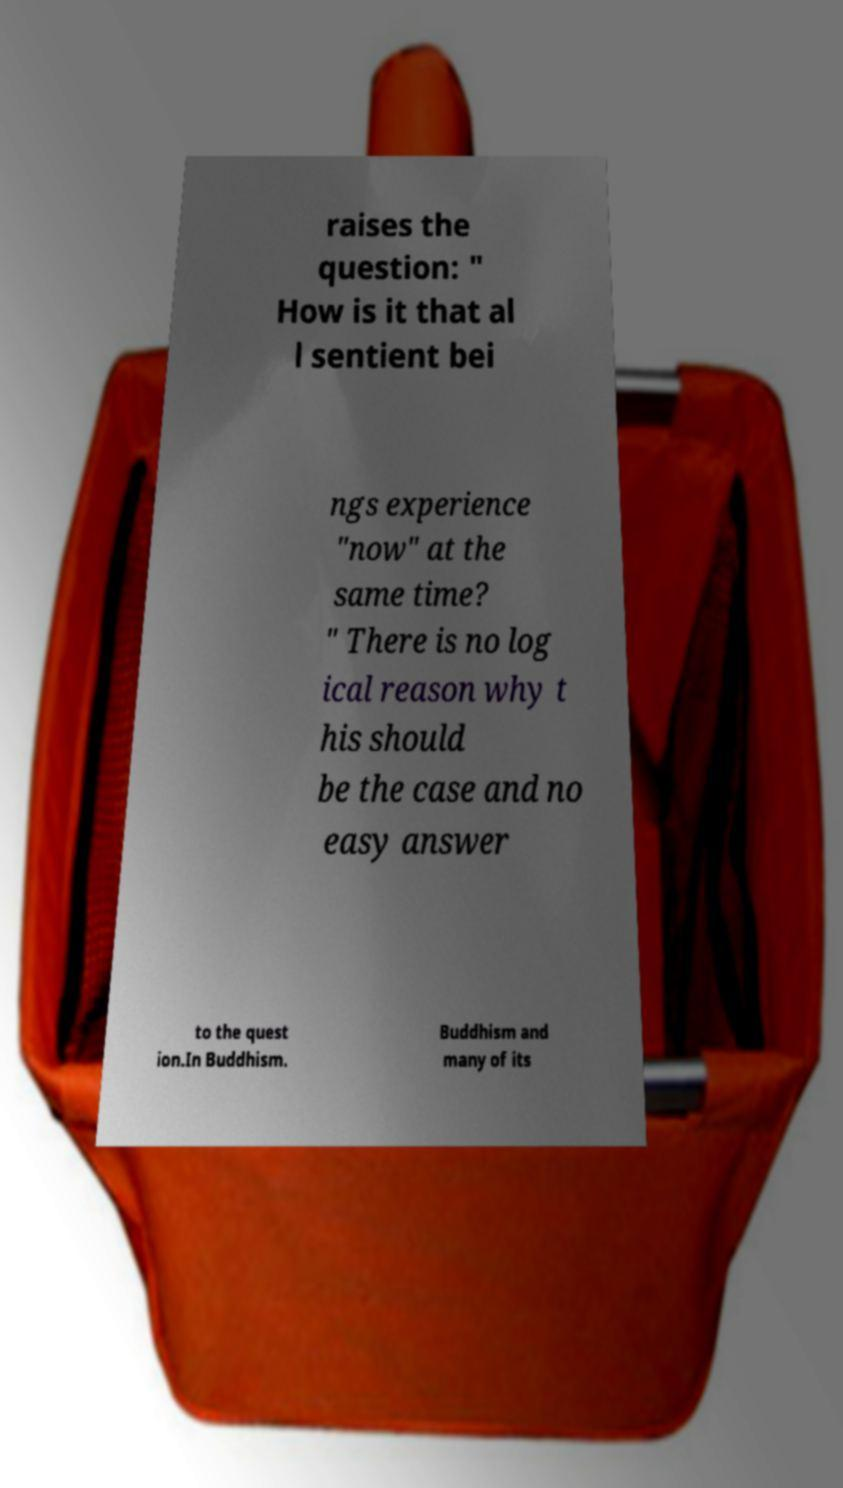Please identify and transcribe the text found in this image. raises the question: " How is it that al l sentient bei ngs experience "now" at the same time? " There is no log ical reason why t his should be the case and no easy answer to the quest ion.In Buddhism. Buddhism and many of its 